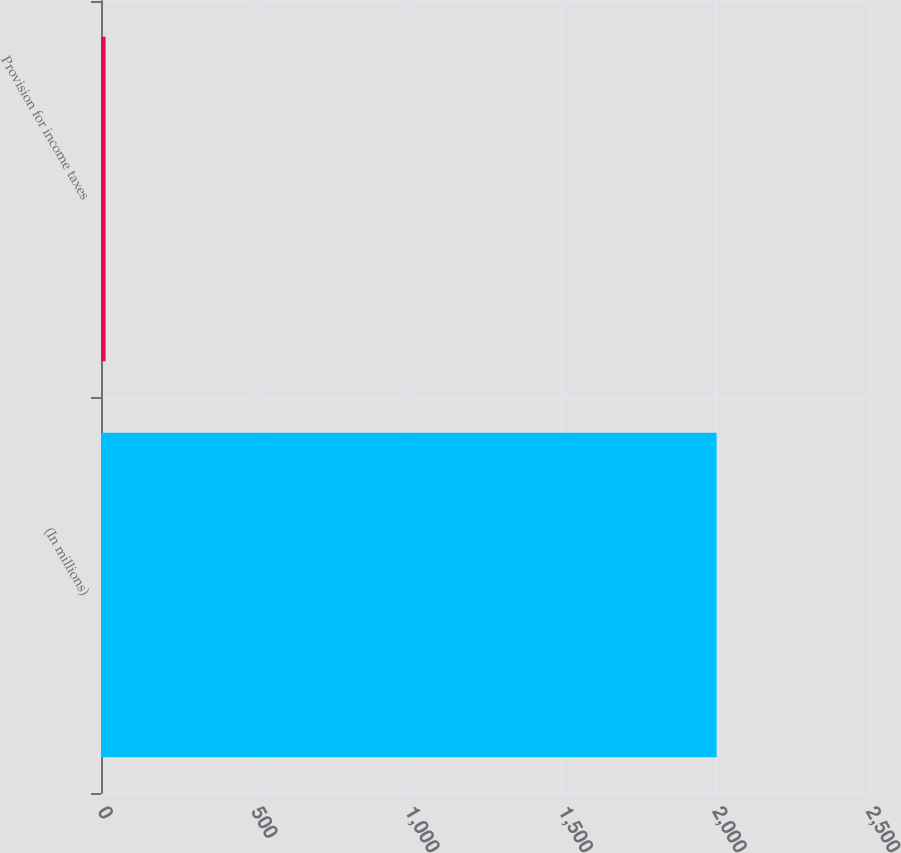<chart> <loc_0><loc_0><loc_500><loc_500><bar_chart><fcel>(In millions)<fcel>Provision for income taxes<nl><fcel>2004<fcel>15<nl></chart> 